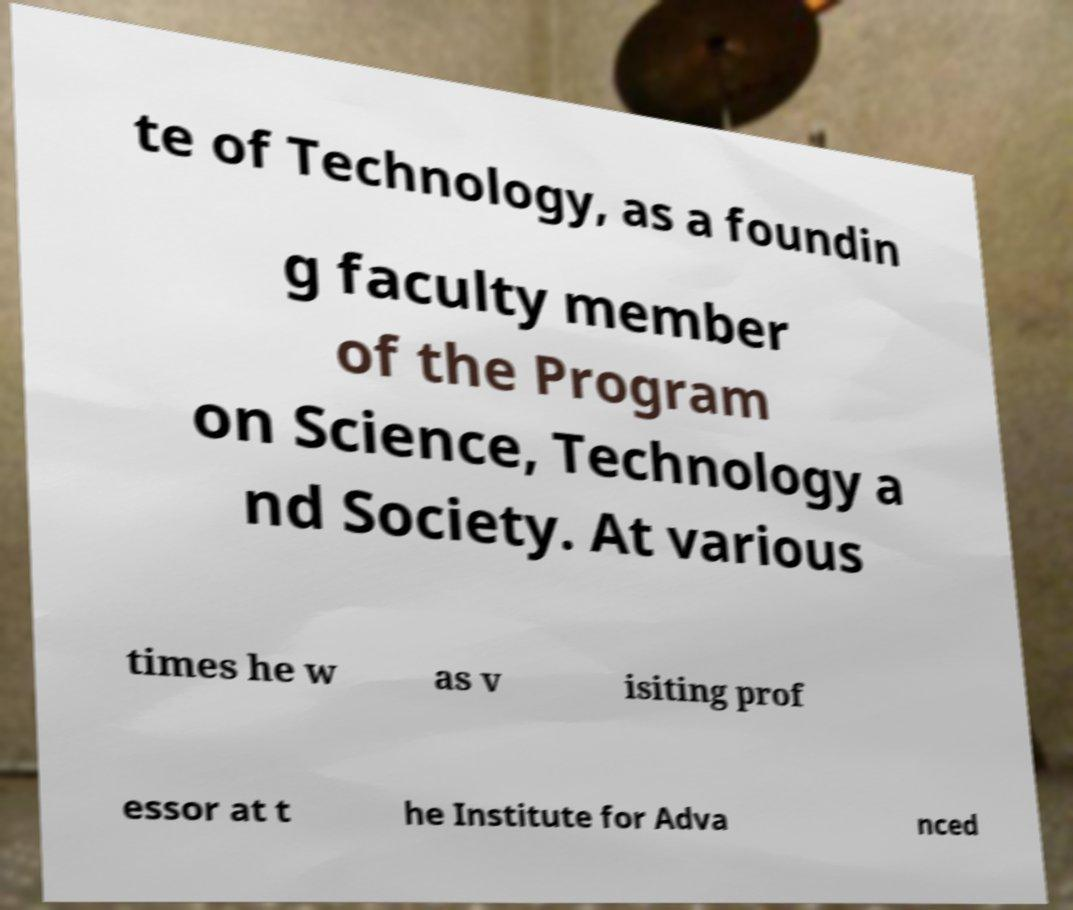What messages or text are displayed in this image? I need them in a readable, typed format. te of Technology, as a foundin g faculty member of the Program on Science, Technology a nd Society. At various times he w as v isiting prof essor at t he Institute for Adva nced 